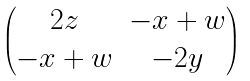<formula> <loc_0><loc_0><loc_500><loc_500>\begin{pmatrix} 2 z & - x + w \\ - x + w & - 2 y \end{pmatrix}</formula> 